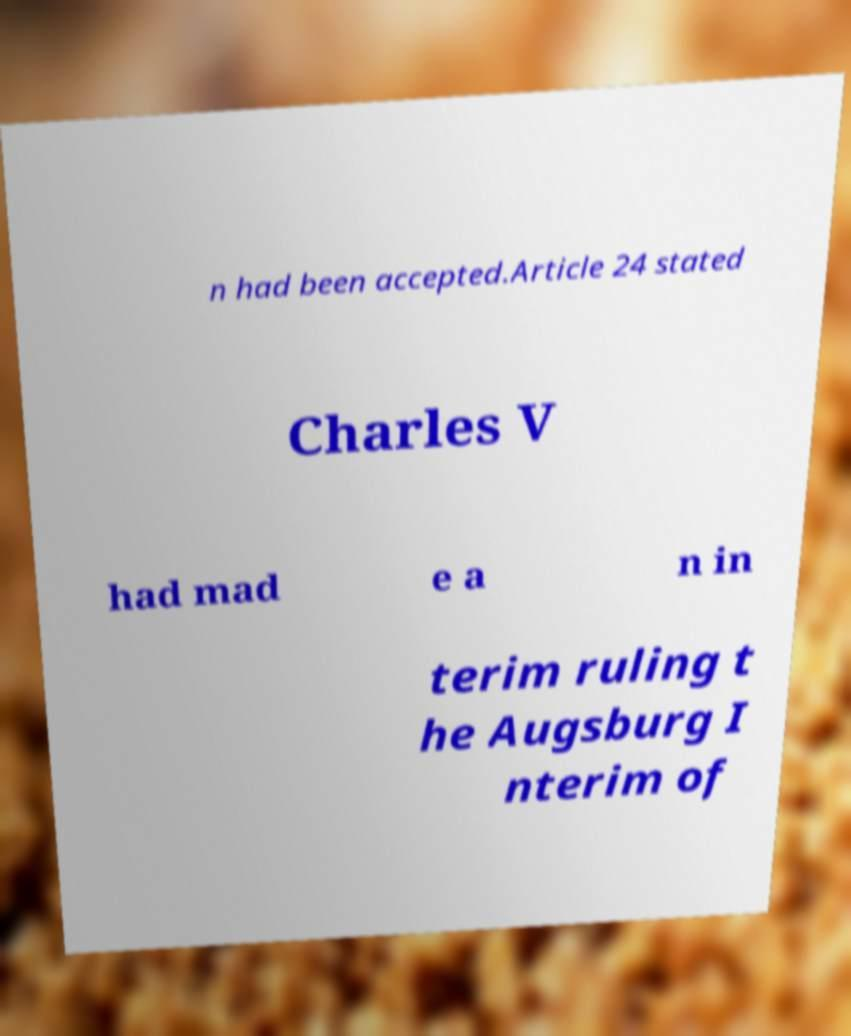Could you assist in decoding the text presented in this image and type it out clearly? n had been accepted.Article 24 stated Charles V had mad e a n in terim ruling t he Augsburg I nterim of 